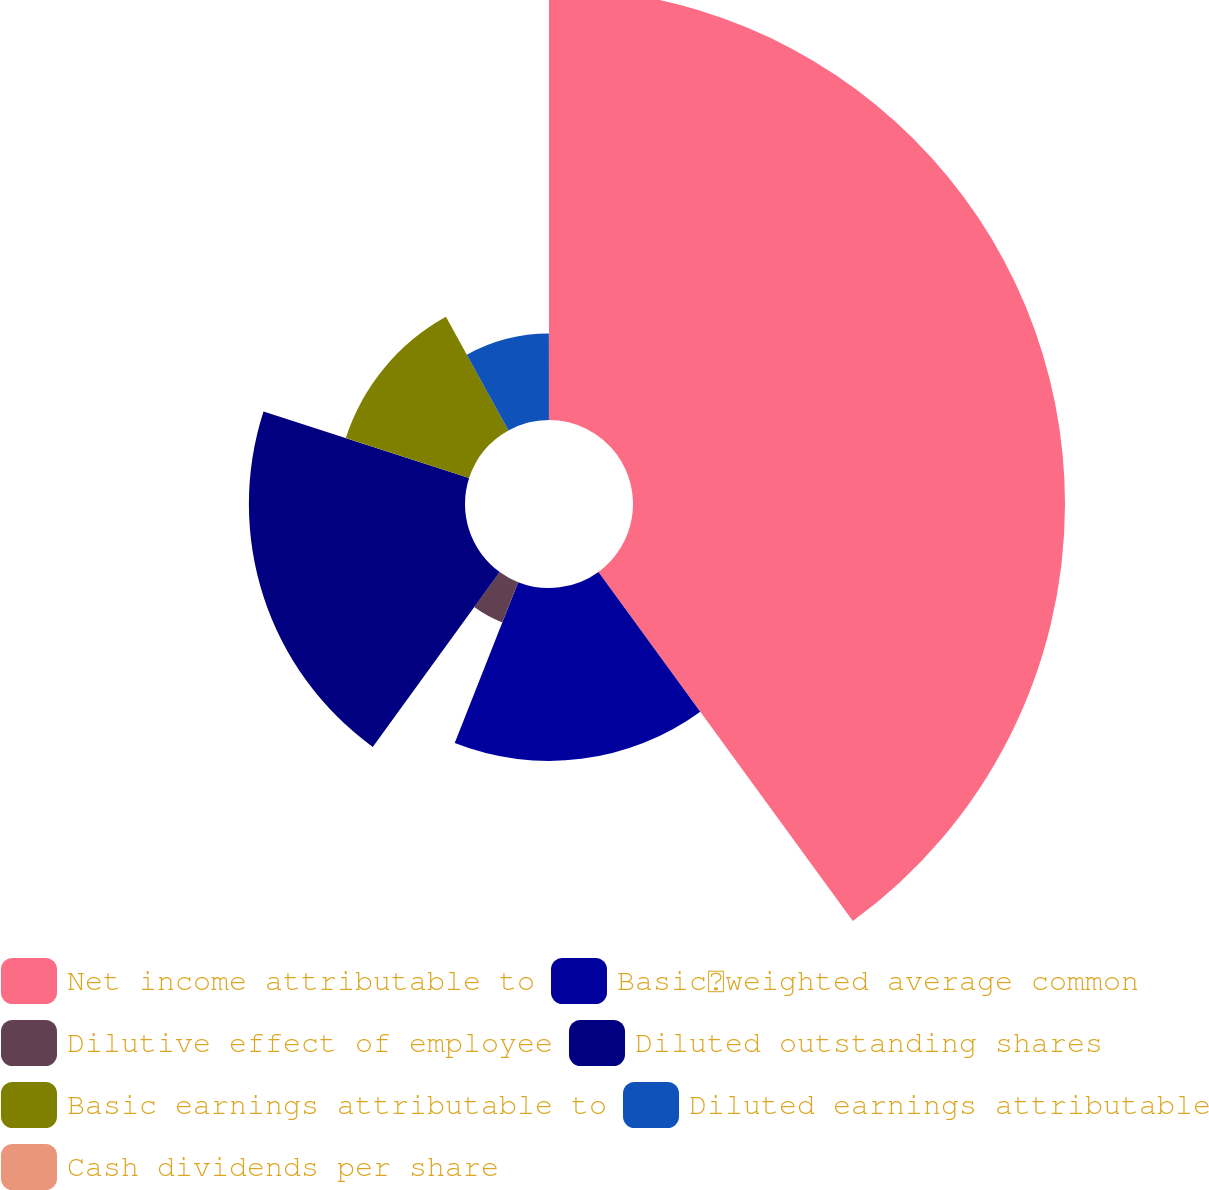<chart> <loc_0><loc_0><loc_500><loc_500><pie_chart><fcel>Net income attributable to<fcel>Basicweighted average common<fcel>Dilutive effect of employee<fcel>Diluted outstanding shares<fcel>Basic earnings attributable to<fcel>Diluted earnings attributable<fcel>Cash dividends per share<nl><fcel>39.98%<fcel>16.0%<fcel>4.01%<fcel>20.0%<fcel>12.0%<fcel>8.0%<fcel>0.01%<nl></chart> 